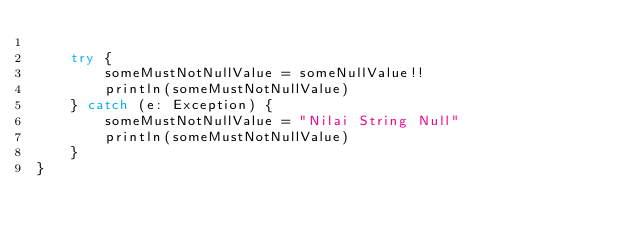Convert code to text. <code><loc_0><loc_0><loc_500><loc_500><_Kotlin_>
    try {
        someMustNotNullValue = someNullValue!!
        println(someMustNotNullValue)
    } catch (e: Exception) {
        someMustNotNullValue = "Nilai String Null"
        println(someMustNotNullValue)
    }
}</code> 